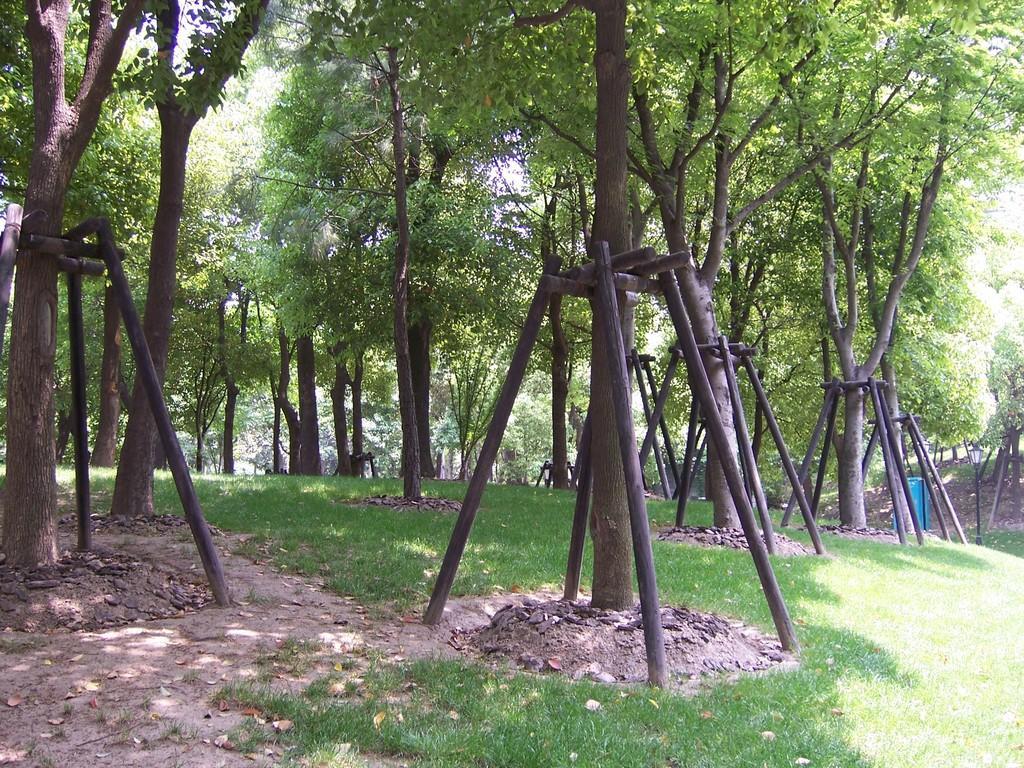Could you give a brief overview of what you see in this image? In this image I can see trees and wooden stands. 